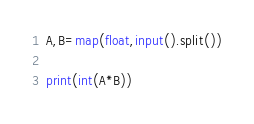Convert code to text. <code><loc_0><loc_0><loc_500><loc_500><_Python_>A,B=map(float,input().split())

print(int(A*B))
</code> 